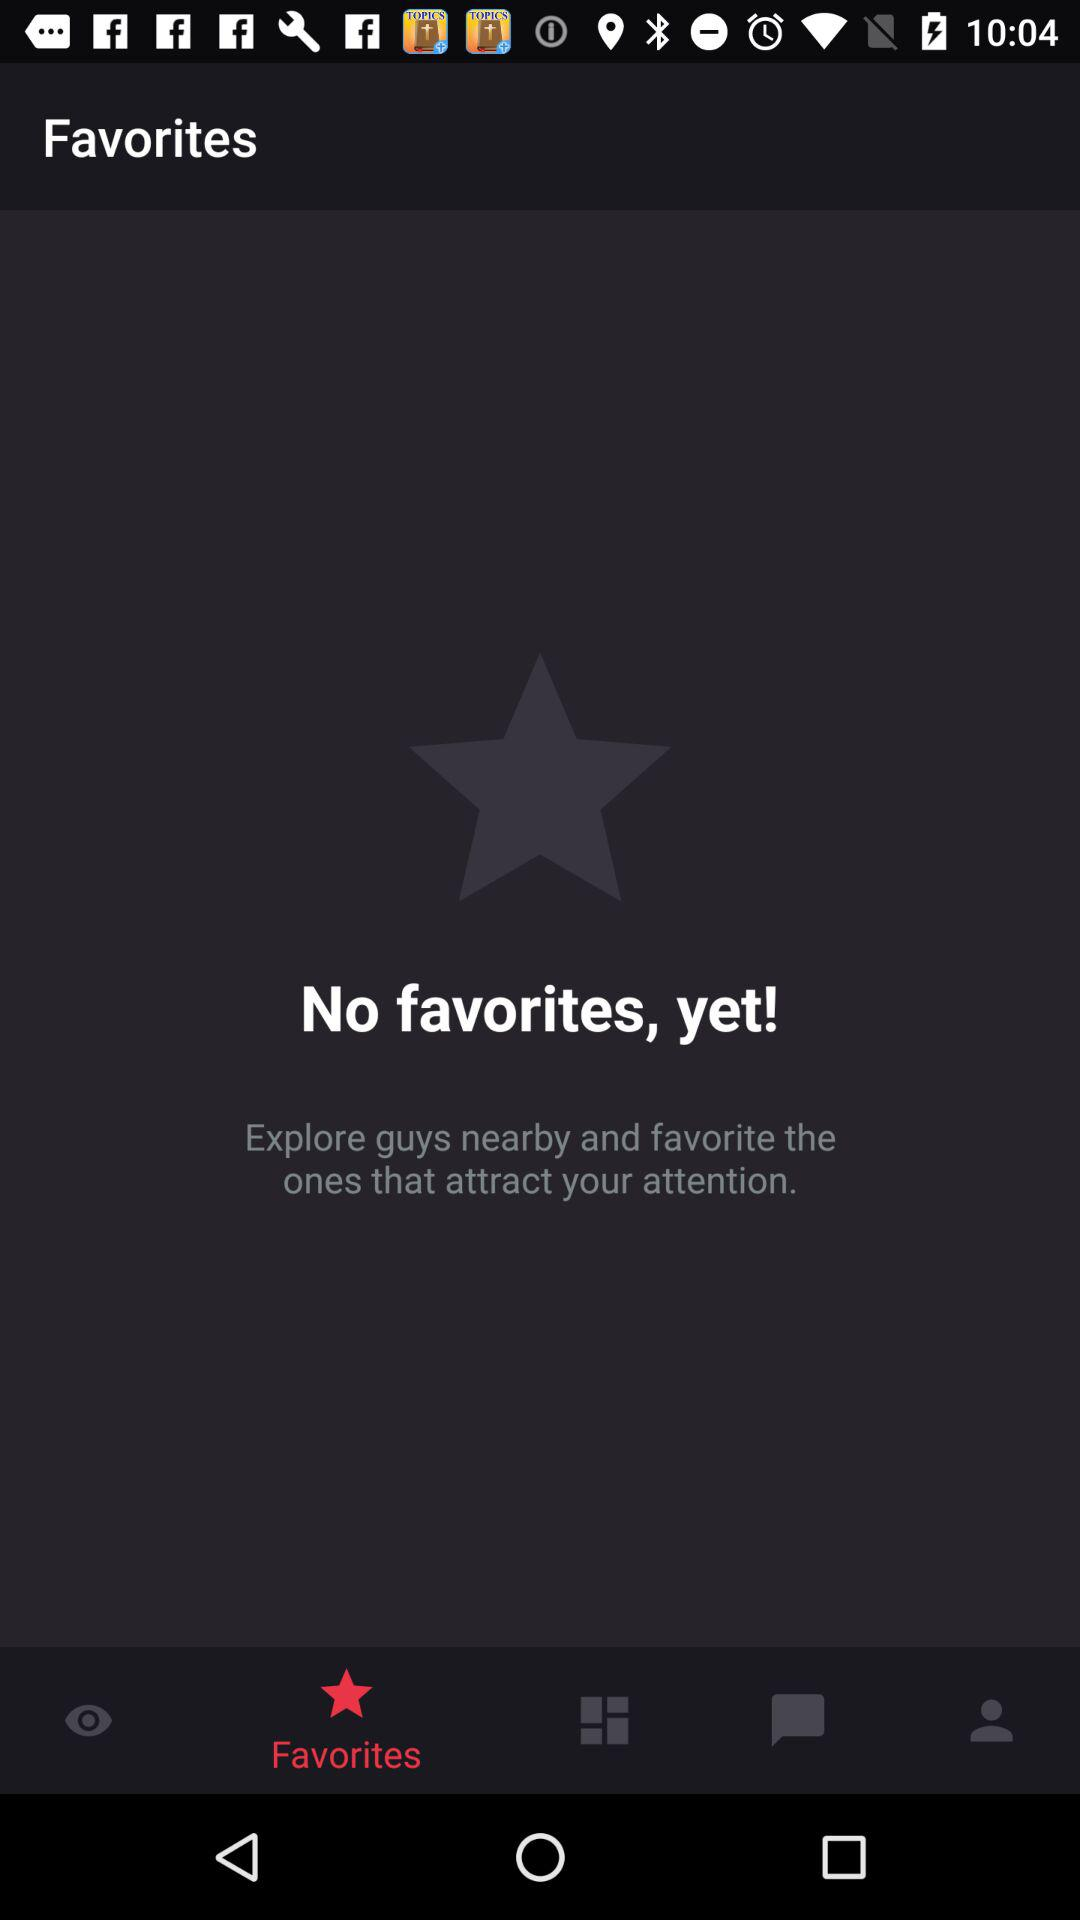Which tab is selected? The selected tab is "Favorites". 